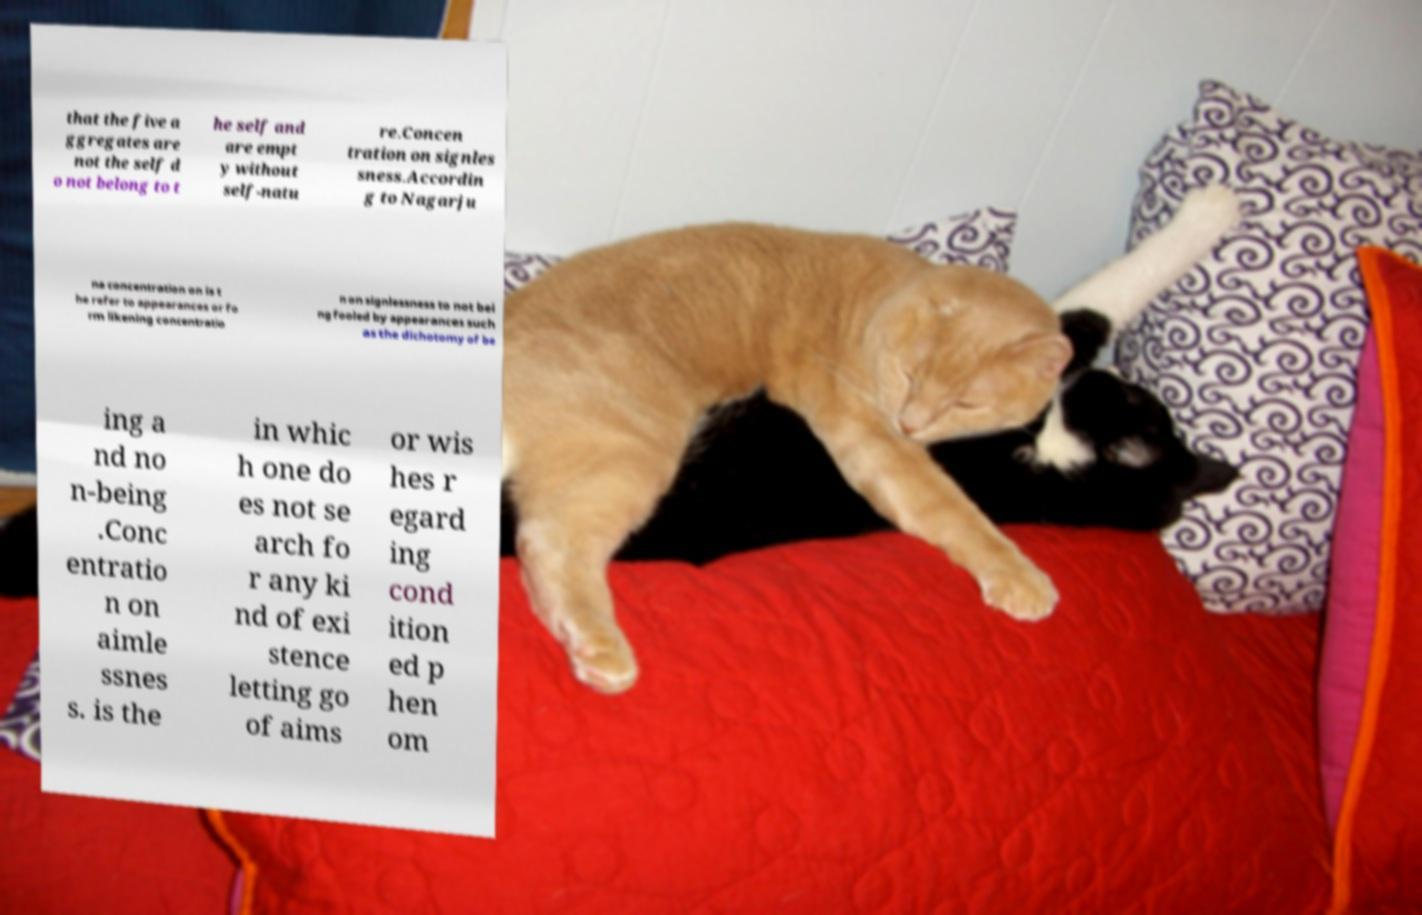Could you assist in decoding the text presented in this image and type it out clearly? that the five a ggregates are not the self d o not belong to t he self and are empt y without self-natu re.Concen tration on signles sness.Accordin g to Nagarju na concentration on is t he refer to appearances or fo rm likening concentratio n on signlessness to not bei ng fooled by appearances such as the dichotomy of be ing a nd no n-being .Conc entratio n on aimle ssnes s. is the in whic h one do es not se arch fo r any ki nd of exi stence letting go of aims or wis hes r egard ing cond ition ed p hen om 